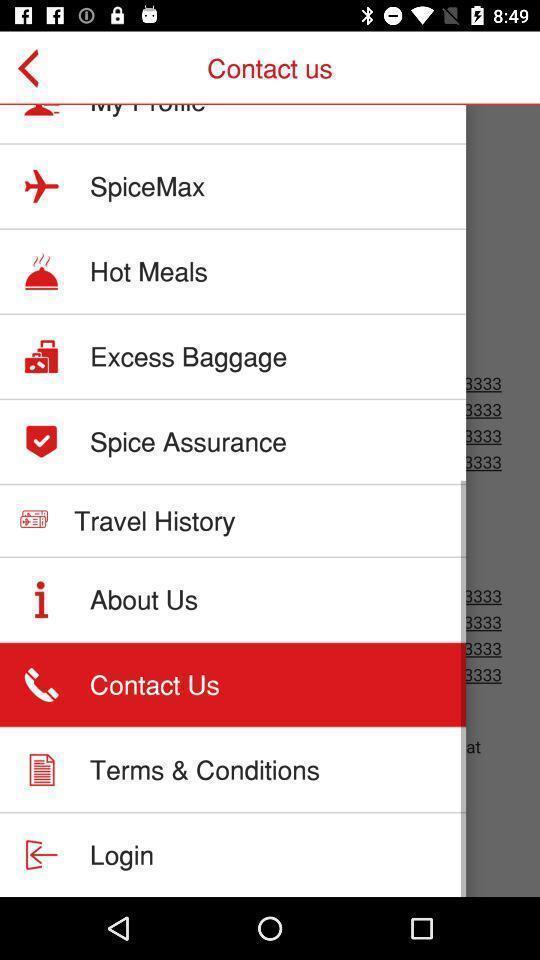Describe the key features of this screenshot. Screen shows multiple options in a travel application. 